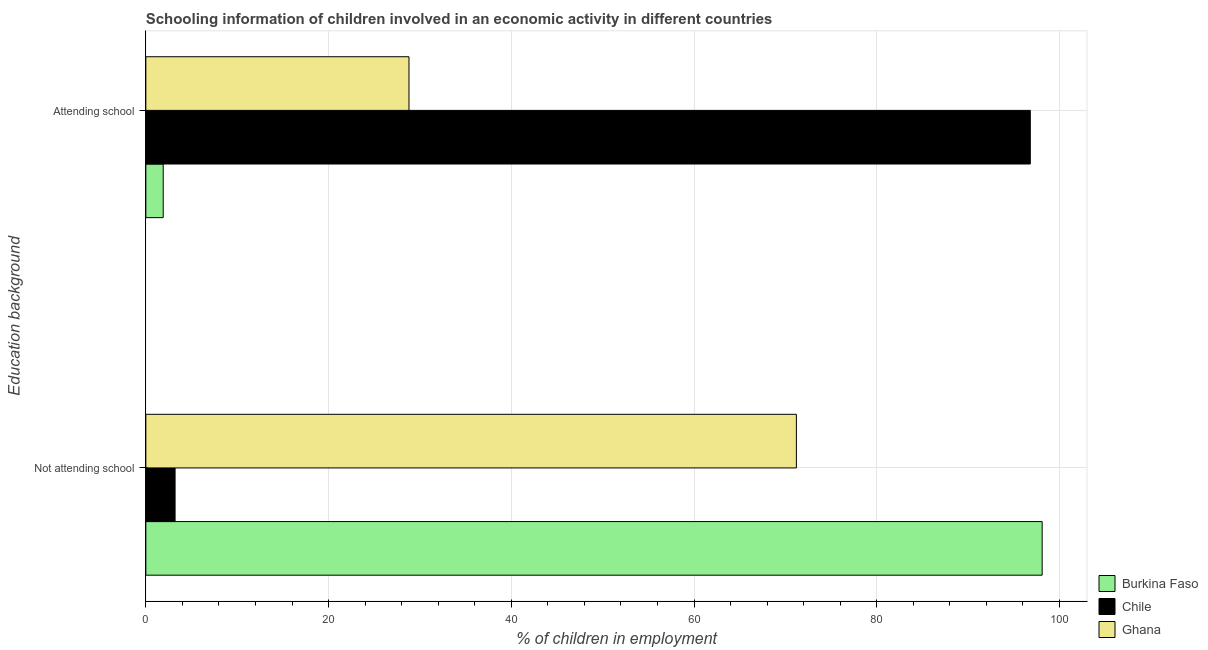How many different coloured bars are there?
Offer a very short reply. 3. Are the number of bars on each tick of the Y-axis equal?
Keep it short and to the point. Yes. How many bars are there on the 2nd tick from the top?
Your response must be concise. 3. What is the label of the 2nd group of bars from the top?
Offer a very short reply. Not attending school. What is the percentage of employed children who are not attending school in Chile?
Your answer should be very brief. 3.2. Across all countries, what is the maximum percentage of employed children who are not attending school?
Provide a succinct answer. 98.1. Across all countries, what is the minimum percentage of employed children who are attending school?
Provide a succinct answer. 1.9. In which country was the percentage of employed children who are not attending school maximum?
Make the answer very short. Burkina Faso. In which country was the percentage of employed children who are not attending school minimum?
Your answer should be very brief. Chile. What is the total percentage of employed children who are attending school in the graph?
Your response must be concise. 127.5. What is the difference between the percentage of employed children who are attending school in Ghana and that in Chile?
Your answer should be very brief. -68. What is the difference between the percentage of employed children who are not attending school in Chile and the percentage of employed children who are attending school in Ghana?
Provide a short and direct response. -25.6. What is the average percentage of employed children who are attending school per country?
Ensure brevity in your answer.  42.5. What is the difference between the percentage of employed children who are attending school and percentage of employed children who are not attending school in Chile?
Make the answer very short. 93.6. What is the ratio of the percentage of employed children who are not attending school in Ghana to that in Burkina Faso?
Provide a short and direct response. 0.73. In how many countries, is the percentage of employed children who are attending school greater than the average percentage of employed children who are attending school taken over all countries?
Provide a succinct answer. 1. What does the 2nd bar from the top in Attending school represents?
Your answer should be compact. Chile. What does the 1st bar from the bottom in Not attending school represents?
Your answer should be compact. Burkina Faso. Does the graph contain grids?
Offer a very short reply. Yes. Where does the legend appear in the graph?
Ensure brevity in your answer.  Bottom right. How many legend labels are there?
Your answer should be very brief. 3. What is the title of the graph?
Your answer should be compact. Schooling information of children involved in an economic activity in different countries. What is the label or title of the X-axis?
Your response must be concise. % of children in employment. What is the label or title of the Y-axis?
Make the answer very short. Education background. What is the % of children in employment in Burkina Faso in Not attending school?
Give a very brief answer. 98.1. What is the % of children in employment of Ghana in Not attending school?
Give a very brief answer. 71.2. What is the % of children in employment in Burkina Faso in Attending school?
Give a very brief answer. 1.9. What is the % of children in employment of Chile in Attending school?
Your response must be concise. 96.8. What is the % of children in employment of Ghana in Attending school?
Your answer should be compact. 28.8. Across all Education background, what is the maximum % of children in employment of Burkina Faso?
Give a very brief answer. 98.1. Across all Education background, what is the maximum % of children in employment in Chile?
Provide a succinct answer. 96.8. Across all Education background, what is the maximum % of children in employment in Ghana?
Your answer should be compact. 71.2. Across all Education background, what is the minimum % of children in employment of Burkina Faso?
Your answer should be very brief. 1.9. Across all Education background, what is the minimum % of children in employment of Chile?
Offer a very short reply. 3.2. Across all Education background, what is the minimum % of children in employment of Ghana?
Provide a short and direct response. 28.8. What is the total % of children in employment in Burkina Faso in the graph?
Your answer should be very brief. 100. What is the total % of children in employment in Chile in the graph?
Provide a short and direct response. 100. What is the difference between the % of children in employment in Burkina Faso in Not attending school and that in Attending school?
Provide a short and direct response. 96.2. What is the difference between the % of children in employment of Chile in Not attending school and that in Attending school?
Your answer should be compact. -93.6. What is the difference between the % of children in employment in Ghana in Not attending school and that in Attending school?
Give a very brief answer. 42.4. What is the difference between the % of children in employment in Burkina Faso in Not attending school and the % of children in employment in Ghana in Attending school?
Make the answer very short. 69.3. What is the difference between the % of children in employment in Chile in Not attending school and the % of children in employment in Ghana in Attending school?
Ensure brevity in your answer.  -25.6. What is the average % of children in employment of Burkina Faso per Education background?
Your answer should be very brief. 50. What is the average % of children in employment in Chile per Education background?
Make the answer very short. 50. What is the difference between the % of children in employment in Burkina Faso and % of children in employment in Chile in Not attending school?
Offer a terse response. 94.9. What is the difference between the % of children in employment in Burkina Faso and % of children in employment in Ghana in Not attending school?
Ensure brevity in your answer.  26.9. What is the difference between the % of children in employment in Chile and % of children in employment in Ghana in Not attending school?
Your response must be concise. -68. What is the difference between the % of children in employment in Burkina Faso and % of children in employment in Chile in Attending school?
Provide a succinct answer. -94.9. What is the difference between the % of children in employment of Burkina Faso and % of children in employment of Ghana in Attending school?
Make the answer very short. -26.9. What is the ratio of the % of children in employment of Burkina Faso in Not attending school to that in Attending school?
Give a very brief answer. 51.63. What is the ratio of the % of children in employment in Chile in Not attending school to that in Attending school?
Your answer should be compact. 0.03. What is the ratio of the % of children in employment in Ghana in Not attending school to that in Attending school?
Offer a very short reply. 2.47. What is the difference between the highest and the second highest % of children in employment of Burkina Faso?
Your answer should be very brief. 96.2. What is the difference between the highest and the second highest % of children in employment in Chile?
Provide a short and direct response. 93.6. What is the difference between the highest and the second highest % of children in employment in Ghana?
Your answer should be very brief. 42.4. What is the difference between the highest and the lowest % of children in employment in Burkina Faso?
Your answer should be compact. 96.2. What is the difference between the highest and the lowest % of children in employment of Chile?
Offer a terse response. 93.6. What is the difference between the highest and the lowest % of children in employment in Ghana?
Your answer should be compact. 42.4. 